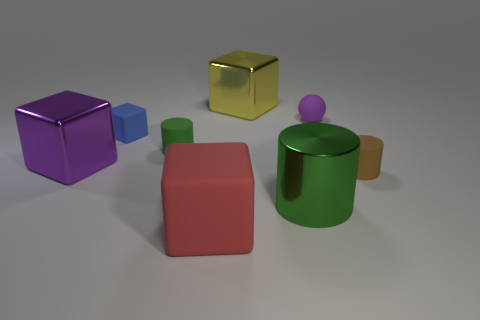There is a cylinder that is to the left of the metallic thing that is on the right side of the yellow cube; how many green rubber cylinders are in front of it? 0 